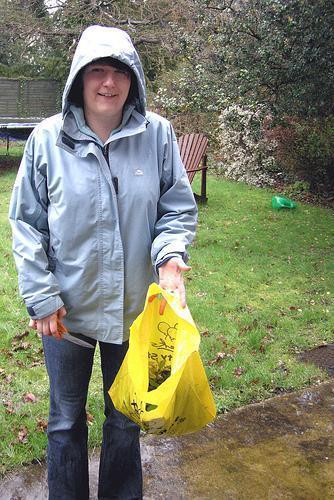How many people are in this photo?
Give a very brief answer. 1. 